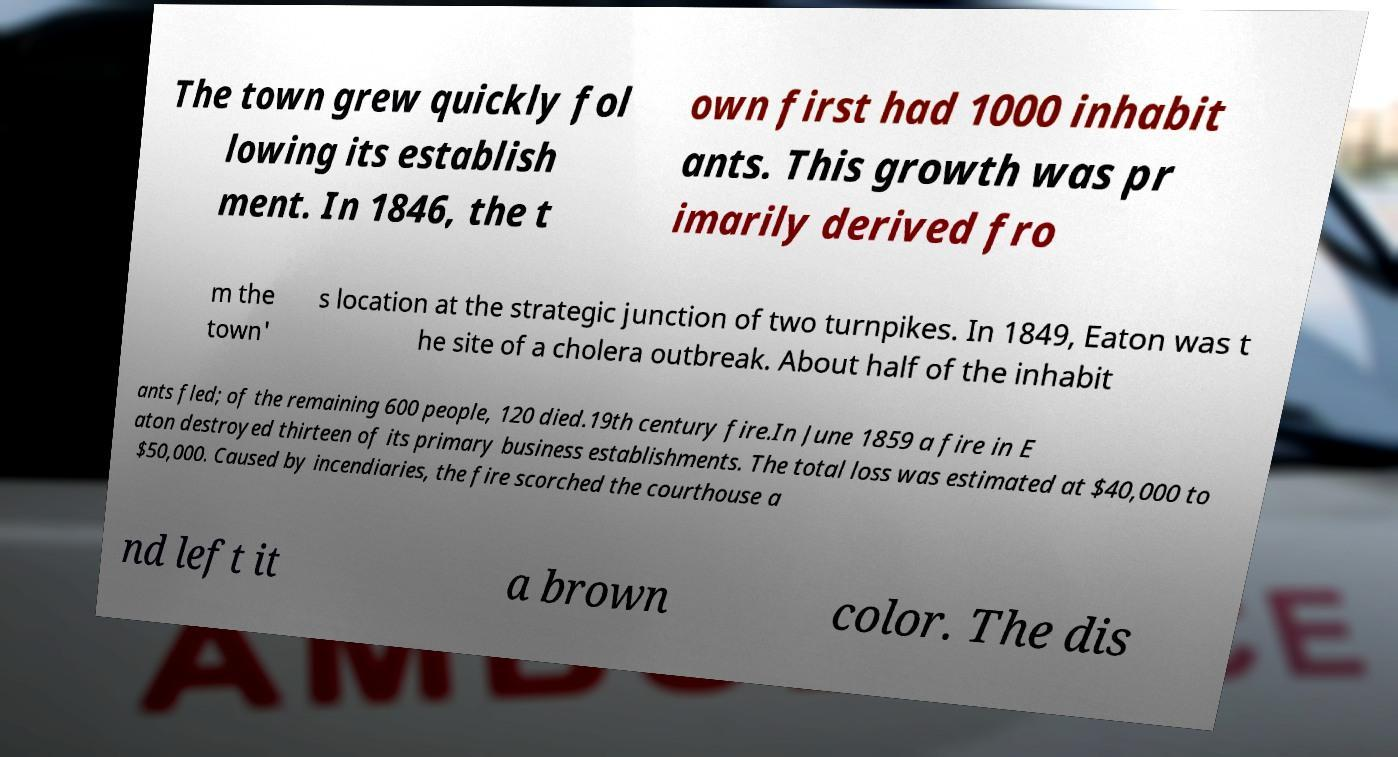Can you read and provide the text displayed in the image?This photo seems to have some interesting text. Can you extract and type it out for me? The town grew quickly fol lowing its establish ment. In 1846, the t own first had 1000 inhabit ants. This growth was pr imarily derived fro m the town' s location at the strategic junction of two turnpikes. In 1849, Eaton was t he site of a cholera outbreak. About half of the inhabit ants fled; of the remaining 600 people, 120 died.19th century fire.In June 1859 a fire in E aton destroyed thirteen of its primary business establishments. The total loss was estimated at $40,000 to $50,000. Caused by incendiaries, the fire scorched the courthouse a nd left it a brown color. The dis 